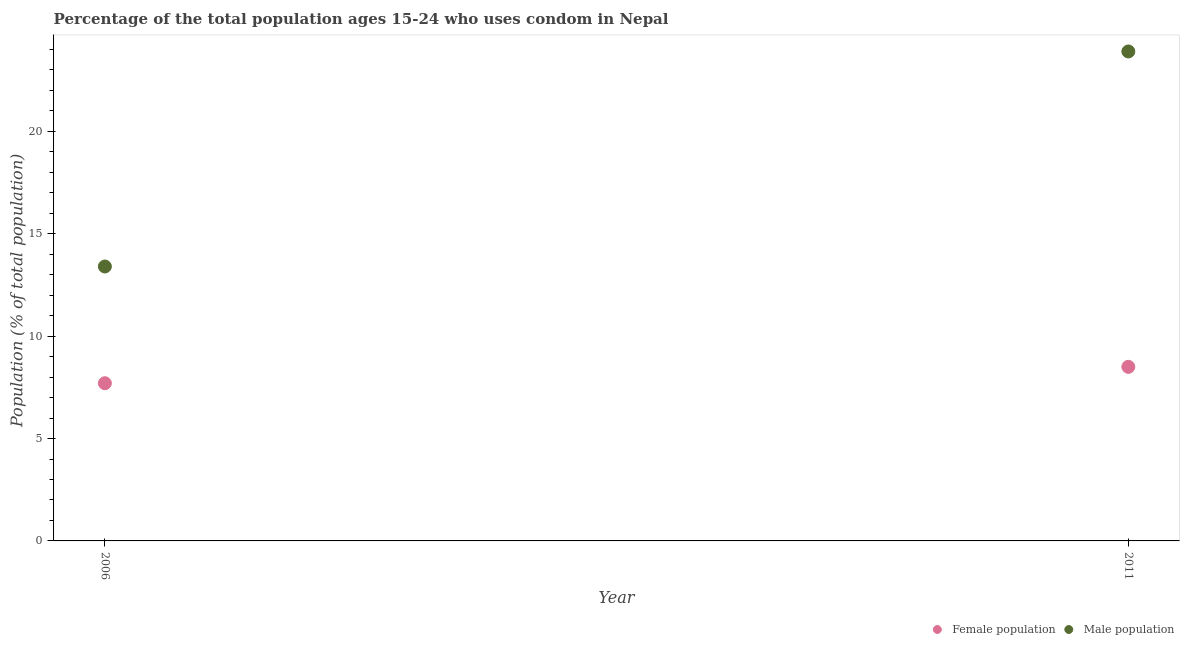Across all years, what is the minimum male population?
Provide a short and direct response. 13.4. In which year was the female population minimum?
Make the answer very short. 2006. What is the total male population in the graph?
Your response must be concise. 37.3. What is the difference between the female population in 2006 and that in 2011?
Provide a succinct answer. -0.8. What is the average female population per year?
Your response must be concise. 8.1. In the year 2011, what is the difference between the female population and male population?
Provide a short and direct response. -15.4. What is the ratio of the male population in 2006 to that in 2011?
Offer a terse response. 0.56. Is the female population in 2006 less than that in 2011?
Your answer should be very brief. Yes. Does the male population monotonically increase over the years?
Provide a short and direct response. Yes. Is the female population strictly less than the male population over the years?
Ensure brevity in your answer.  Yes. How many dotlines are there?
Your response must be concise. 2. How many years are there in the graph?
Provide a short and direct response. 2. What is the difference between two consecutive major ticks on the Y-axis?
Your answer should be compact. 5. How many legend labels are there?
Offer a very short reply. 2. What is the title of the graph?
Give a very brief answer. Percentage of the total population ages 15-24 who uses condom in Nepal. Does "Domestic liabilities" appear as one of the legend labels in the graph?
Give a very brief answer. No. What is the label or title of the Y-axis?
Provide a short and direct response. Population (% of total population) . What is the Population (% of total population)  of Female population in 2006?
Offer a terse response. 7.7. What is the Population (% of total population)  in Male population in 2006?
Give a very brief answer. 13.4. What is the Population (% of total population)  of Male population in 2011?
Your answer should be compact. 23.9. Across all years, what is the maximum Population (% of total population)  of Male population?
Offer a very short reply. 23.9. Across all years, what is the minimum Population (% of total population)  in Female population?
Keep it short and to the point. 7.7. Across all years, what is the minimum Population (% of total population)  of Male population?
Provide a succinct answer. 13.4. What is the total Population (% of total population)  in Male population in the graph?
Your answer should be compact. 37.3. What is the difference between the Population (% of total population)  of Female population in 2006 and that in 2011?
Your answer should be very brief. -0.8. What is the difference between the Population (% of total population)  in Male population in 2006 and that in 2011?
Offer a very short reply. -10.5. What is the difference between the Population (% of total population)  of Female population in 2006 and the Population (% of total population)  of Male population in 2011?
Offer a terse response. -16.2. What is the average Population (% of total population)  of Male population per year?
Keep it short and to the point. 18.65. In the year 2011, what is the difference between the Population (% of total population)  of Female population and Population (% of total population)  of Male population?
Your answer should be compact. -15.4. What is the ratio of the Population (% of total population)  of Female population in 2006 to that in 2011?
Make the answer very short. 0.91. What is the ratio of the Population (% of total population)  in Male population in 2006 to that in 2011?
Provide a short and direct response. 0.56. What is the difference between the highest and the lowest Population (% of total population)  of Female population?
Give a very brief answer. 0.8. What is the difference between the highest and the lowest Population (% of total population)  of Male population?
Your response must be concise. 10.5. 